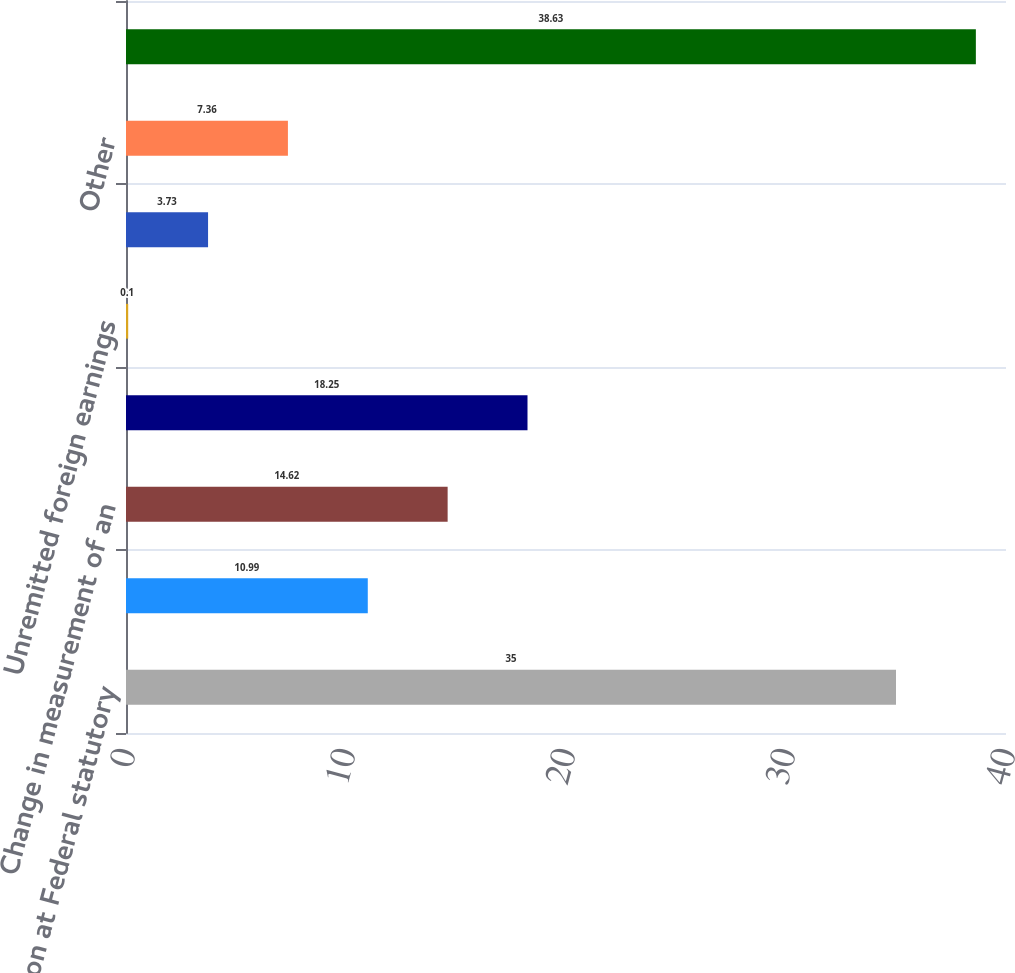Convert chart to OTSL. <chart><loc_0><loc_0><loc_500><loc_500><bar_chart><fcel>Provision at Federal statutory<fcel>State and local income taxes<fcel>Change in measurement of an<fcel>Foreign tax rate differential<fcel>Unremitted foreign earnings<fcel>Valuation allowances<fcel>Other<fcel>Effective income tax rate<nl><fcel>35<fcel>10.99<fcel>14.62<fcel>18.25<fcel>0.1<fcel>3.73<fcel>7.36<fcel>38.63<nl></chart> 